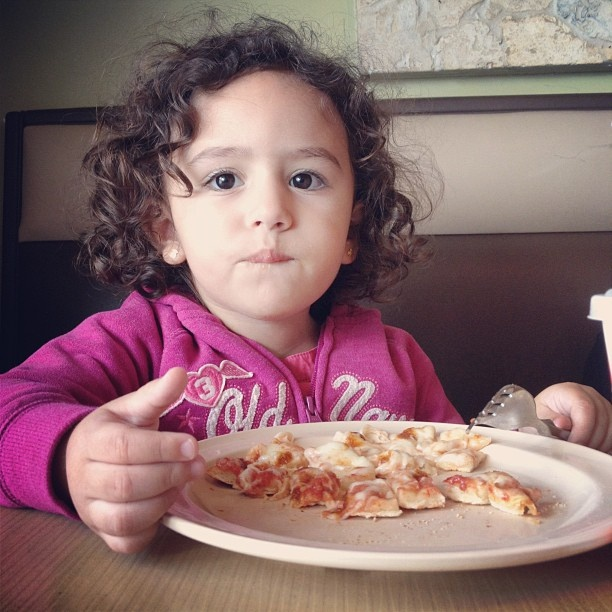Describe the objects in this image and their specific colors. I can see people in black, lightpink, brown, and gray tones, couch in black and brown tones, dining table in black, brown, gray, maroon, and tan tones, pizza in black, tan, and brown tones, and fork in black, darkgray, and gray tones in this image. 